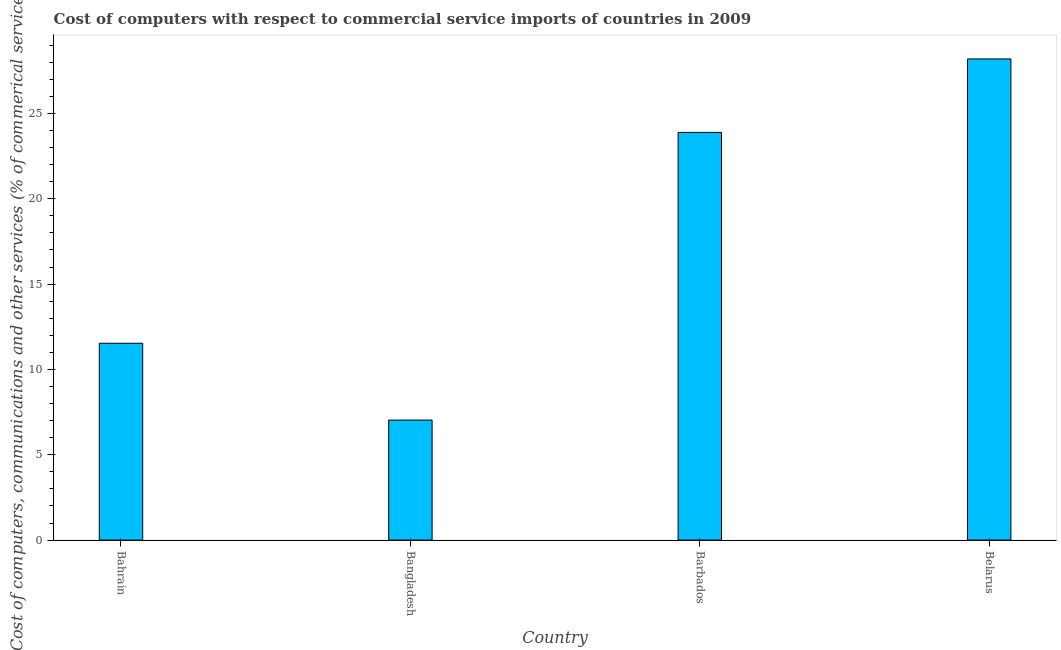What is the title of the graph?
Offer a very short reply. Cost of computers with respect to commercial service imports of countries in 2009. What is the label or title of the X-axis?
Your answer should be compact. Country. What is the label or title of the Y-axis?
Provide a short and direct response. Cost of computers, communications and other services (% of commerical service exports). What is the  computer and other services in Bahrain?
Give a very brief answer. 11.53. Across all countries, what is the maximum cost of communications?
Your answer should be very brief. 28.19. Across all countries, what is the minimum cost of communications?
Give a very brief answer. 7.03. In which country was the  computer and other services maximum?
Ensure brevity in your answer.  Belarus. What is the sum of the  computer and other services?
Keep it short and to the point. 70.65. What is the difference between the cost of communications in Bahrain and Belarus?
Your answer should be very brief. -16.66. What is the average  computer and other services per country?
Give a very brief answer. 17.66. What is the median  computer and other services?
Ensure brevity in your answer.  17.71. What is the ratio of the  computer and other services in Bangladesh to that in Barbados?
Provide a succinct answer. 0.29. Is the cost of communications in Bahrain less than that in Belarus?
Keep it short and to the point. Yes. Is the difference between the  computer and other services in Bahrain and Belarus greater than the difference between any two countries?
Your response must be concise. No. What is the difference between the highest and the second highest cost of communications?
Provide a short and direct response. 4.3. Is the sum of the cost of communications in Bahrain and Bangladesh greater than the maximum cost of communications across all countries?
Provide a short and direct response. No. What is the difference between the highest and the lowest cost of communications?
Your answer should be very brief. 21.16. How many bars are there?
Your answer should be compact. 4. What is the Cost of computers, communications and other services (% of commerical service exports) of Bahrain?
Make the answer very short. 11.53. What is the Cost of computers, communications and other services (% of commerical service exports) of Bangladesh?
Your answer should be compact. 7.03. What is the Cost of computers, communications and other services (% of commerical service exports) of Barbados?
Make the answer very short. 23.89. What is the Cost of computers, communications and other services (% of commerical service exports) of Belarus?
Provide a short and direct response. 28.19. What is the difference between the Cost of computers, communications and other services (% of commerical service exports) in Bahrain and Bangladesh?
Provide a succinct answer. 4.5. What is the difference between the Cost of computers, communications and other services (% of commerical service exports) in Bahrain and Barbados?
Keep it short and to the point. -12.36. What is the difference between the Cost of computers, communications and other services (% of commerical service exports) in Bahrain and Belarus?
Provide a succinct answer. -16.66. What is the difference between the Cost of computers, communications and other services (% of commerical service exports) in Bangladesh and Barbados?
Give a very brief answer. -16.86. What is the difference between the Cost of computers, communications and other services (% of commerical service exports) in Bangladesh and Belarus?
Keep it short and to the point. -21.16. What is the difference between the Cost of computers, communications and other services (% of commerical service exports) in Barbados and Belarus?
Ensure brevity in your answer.  -4.3. What is the ratio of the Cost of computers, communications and other services (% of commerical service exports) in Bahrain to that in Bangladesh?
Ensure brevity in your answer.  1.64. What is the ratio of the Cost of computers, communications and other services (% of commerical service exports) in Bahrain to that in Barbados?
Your answer should be very brief. 0.48. What is the ratio of the Cost of computers, communications and other services (% of commerical service exports) in Bahrain to that in Belarus?
Keep it short and to the point. 0.41. What is the ratio of the Cost of computers, communications and other services (% of commerical service exports) in Bangladesh to that in Barbados?
Offer a terse response. 0.29. What is the ratio of the Cost of computers, communications and other services (% of commerical service exports) in Bangladesh to that in Belarus?
Your answer should be very brief. 0.25. What is the ratio of the Cost of computers, communications and other services (% of commerical service exports) in Barbados to that in Belarus?
Make the answer very short. 0.85. 